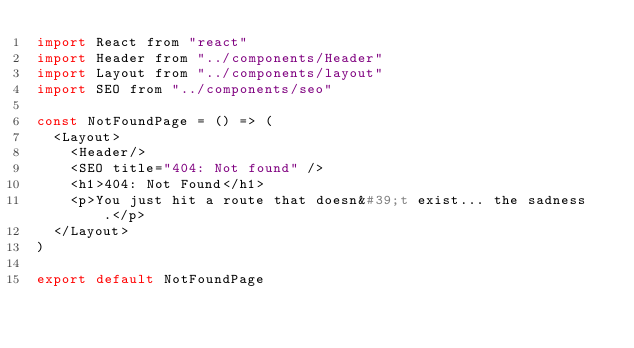Convert code to text. <code><loc_0><loc_0><loc_500><loc_500><_JavaScript_>import React from "react"
import Header from "../components/Header"
import Layout from "../components/layout"
import SEO from "../components/seo"

const NotFoundPage = () => (
  <Layout>
    <Header/>
    <SEO title="404: Not found" />
    <h1>404: Not Found</h1>
    <p>You just hit a route that doesn&#39;t exist... the sadness.</p>
  </Layout>
)

export default NotFoundPage
</code> 